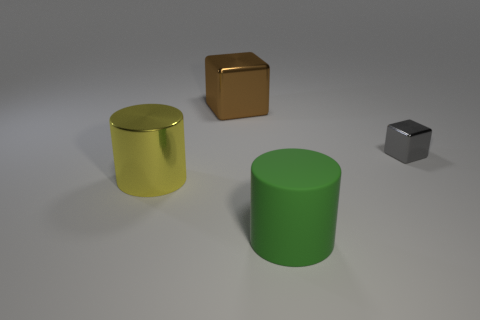Add 1 tiny metallic things. How many objects exist? 5 Subtract all brown cubes. How many cubes are left? 1 Subtract all green blocks. Subtract all green spheres. How many blocks are left? 2 Subtract all brown cylinders. How many cyan blocks are left? 0 Subtract all small gray things. Subtract all cyan metal objects. How many objects are left? 3 Add 1 gray cubes. How many gray cubes are left? 2 Add 2 large rubber cylinders. How many large rubber cylinders exist? 3 Subtract 0 blue balls. How many objects are left? 4 